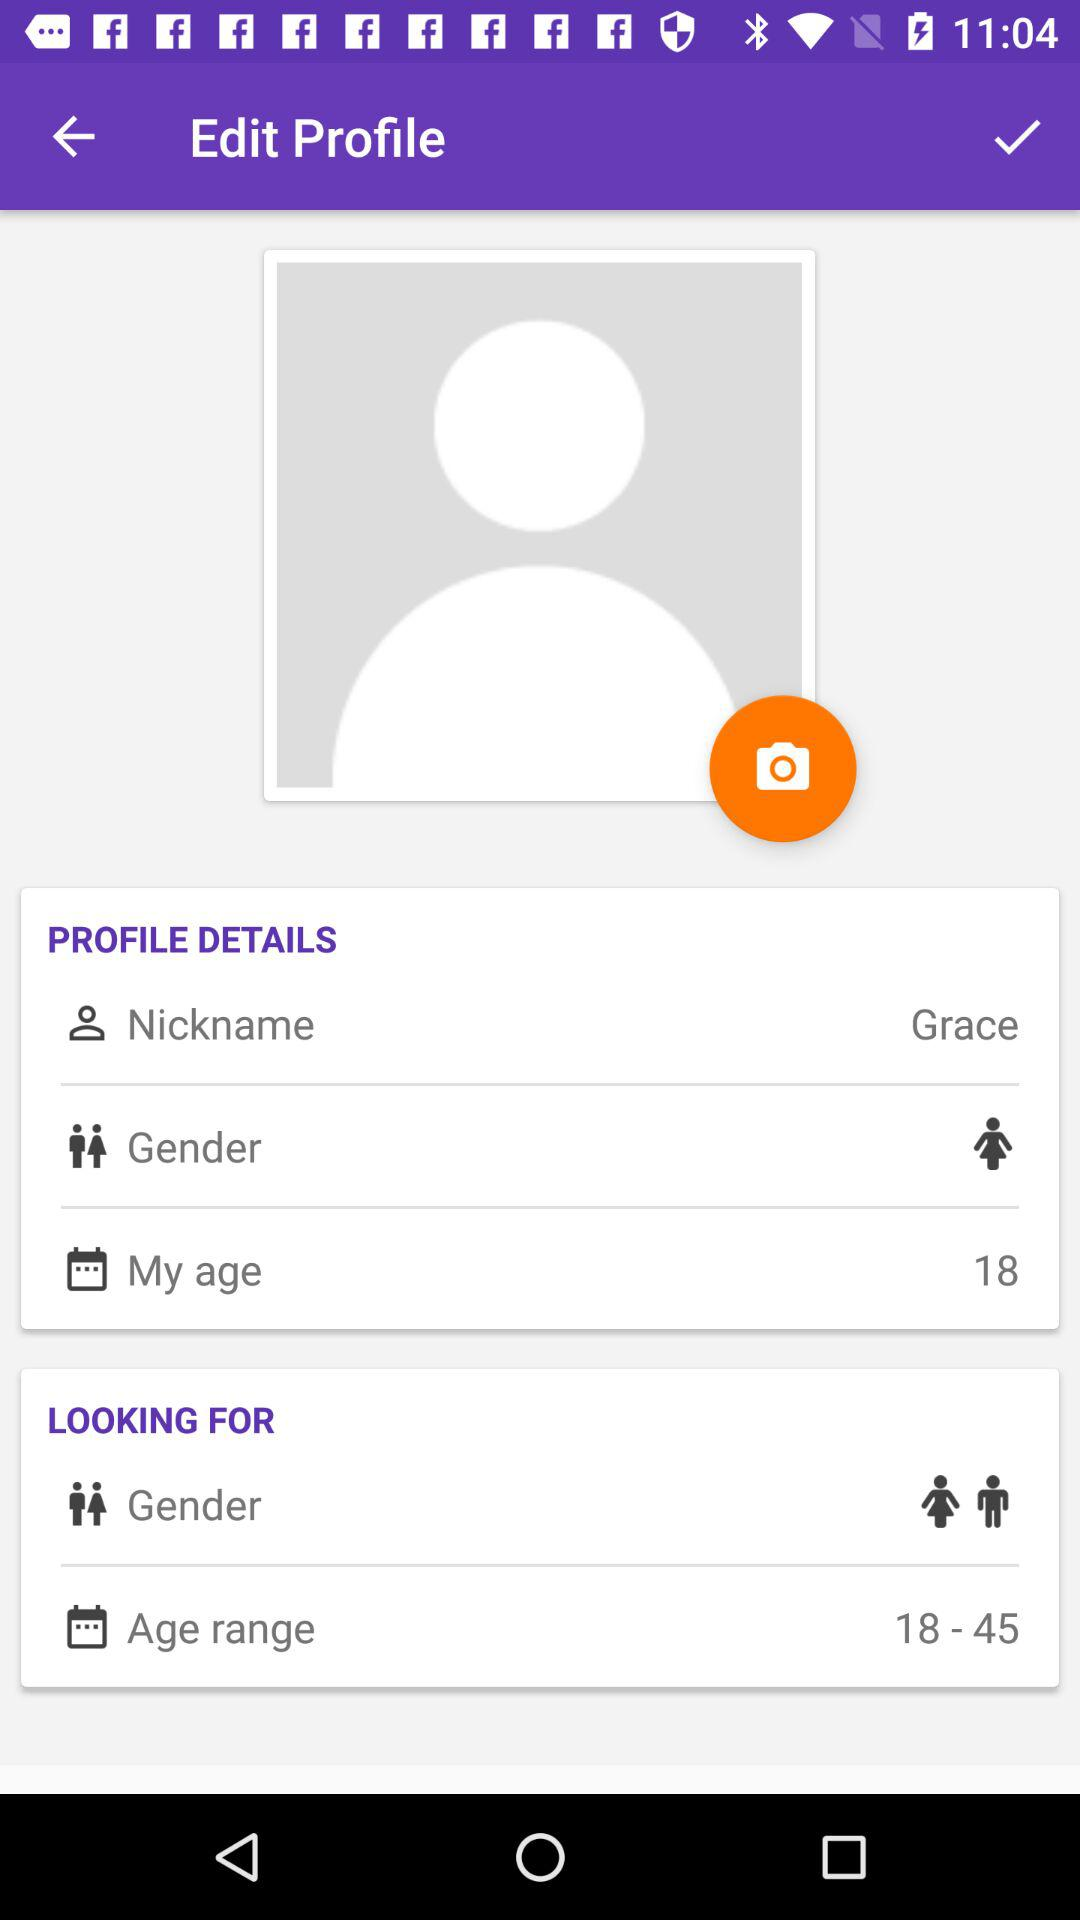What age range is the user looking for? The user is looking for the 18 to 45 age range. 